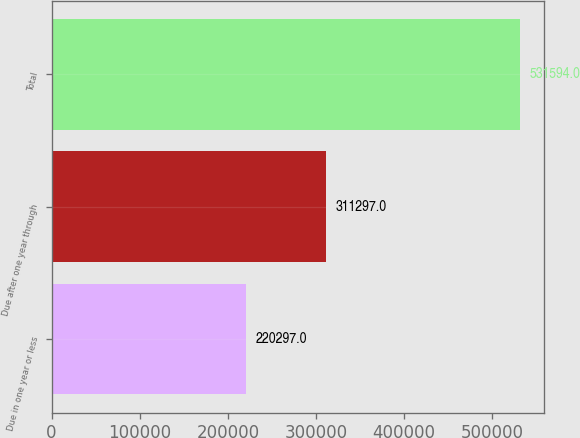Convert chart. <chart><loc_0><loc_0><loc_500><loc_500><bar_chart><fcel>Due in one year or less<fcel>Due after one year through<fcel>Total<nl><fcel>220297<fcel>311297<fcel>531594<nl></chart> 